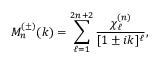Convert formula to latex. <formula><loc_0><loc_0><loc_500><loc_500>M _ { n } ^ { ( \pm ) } ( k ) = \sum _ { \ell = 1 } ^ { 2 n + 2 } \frac { \chi _ { \ell } ^ { ( n ) } } { [ 1 \pm i k ] ^ { \ell } } ,</formula> 